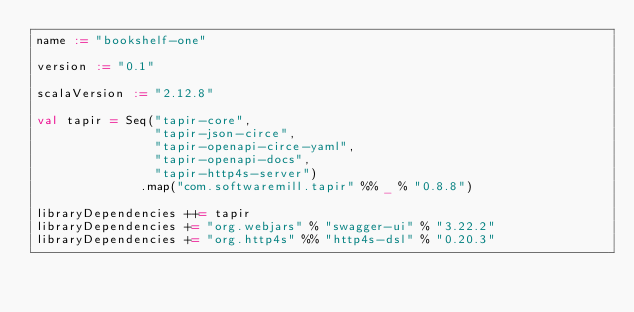<code> <loc_0><loc_0><loc_500><loc_500><_Scala_>name := "bookshelf-one"

version := "0.1"

scalaVersion := "2.12.8"

val tapir = Seq("tapir-core", 
                "tapir-json-circe", 
                "tapir-openapi-circe-yaml",
                "tapir-openapi-docs",
                "tapir-http4s-server")
              .map("com.softwaremill.tapir" %% _ % "0.8.8")

libraryDependencies ++= tapir
libraryDependencies += "org.webjars" % "swagger-ui" % "3.22.2"
libraryDependencies += "org.http4s" %% "http4s-dsl" % "0.20.3"</code> 